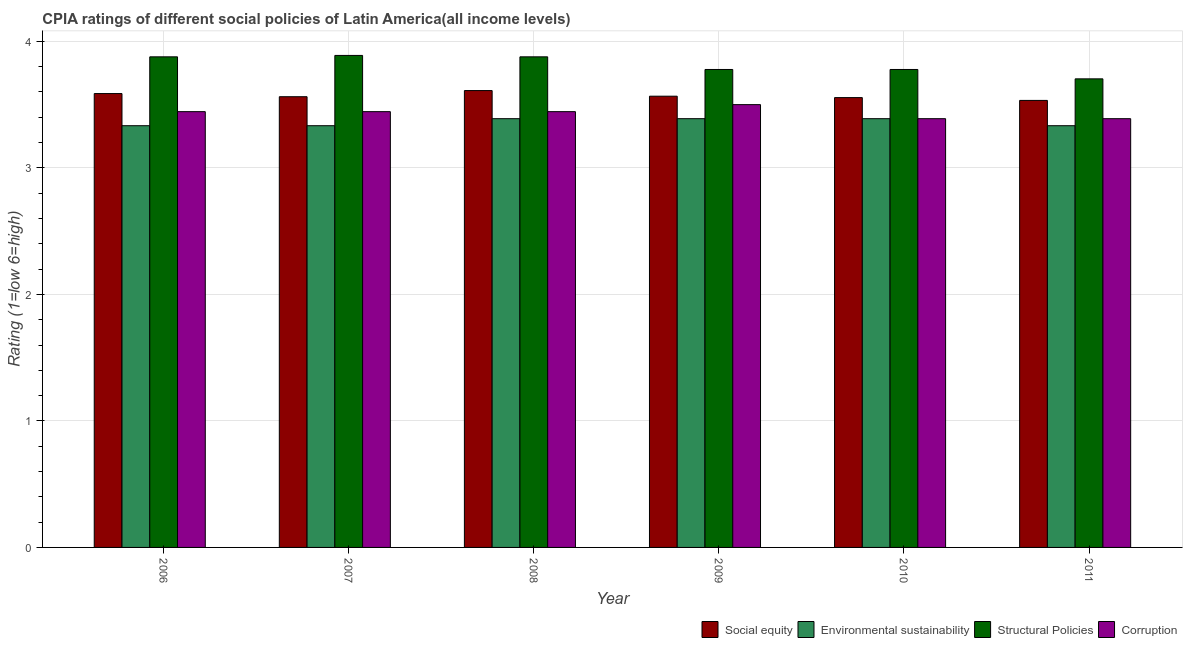How many different coloured bars are there?
Provide a succinct answer. 4. Are the number of bars per tick equal to the number of legend labels?
Provide a succinct answer. Yes. Are the number of bars on each tick of the X-axis equal?
Offer a very short reply. Yes. How many bars are there on the 2nd tick from the right?
Provide a short and direct response. 4. What is the cpia rating of environmental sustainability in 2011?
Ensure brevity in your answer.  3.33. Across all years, what is the maximum cpia rating of social equity?
Your answer should be very brief. 3.61. Across all years, what is the minimum cpia rating of environmental sustainability?
Offer a terse response. 3.33. What is the total cpia rating of environmental sustainability in the graph?
Offer a very short reply. 20.17. What is the difference between the cpia rating of structural policies in 2006 and that in 2007?
Ensure brevity in your answer.  -0.01. What is the difference between the cpia rating of social equity in 2009 and the cpia rating of environmental sustainability in 2011?
Offer a very short reply. 0.03. What is the average cpia rating of environmental sustainability per year?
Ensure brevity in your answer.  3.36. In how many years, is the cpia rating of environmental sustainability greater than 1.2?
Provide a succinct answer. 6. What is the ratio of the cpia rating of social equity in 2006 to that in 2007?
Offer a very short reply. 1.01. Is the cpia rating of environmental sustainability in 2006 less than that in 2009?
Offer a very short reply. Yes. What is the difference between the highest and the second highest cpia rating of social equity?
Provide a succinct answer. 0.02. What is the difference between the highest and the lowest cpia rating of structural policies?
Offer a very short reply. 0.19. Is it the case that in every year, the sum of the cpia rating of corruption and cpia rating of environmental sustainability is greater than the sum of cpia rating of social equity and cpia rating of structural policies?
Provide a succinct answer. Yes. What does the 2nd bar from the left in 2007 represents?
Your answer should be very brief. Environmental sustainability. What does the 1st bar from the right in 2007 represents?
Offer a terse response. Corruption. How many bars are there?
Give a very brief answer. 24. Are all the bars in the graph horizontal?
Your answer should be very brief. No. How many years are there in the graph?
Provide a short and direct response. 6. Does the graph contain any zero values?
Offer a very short reply. No. Does the graph contain grids?
Your response must be concise. Yes. How many legend labels are there?
Ensure brevity in your answer.  4. What is the title of the graph?
Your answer should be compact. CPIA ratings of different social policies of Latin America(all income levels). Does "First 20% of population" appear as one of the legend labels in the graph?
Offer a very short reply. No. What is the Rating (1=low 6=high) of Social equity in 2006?
Keep it short and to the point. 3.59. What is the Rating (1=low 6=high) of Environmental sustainability in 2006?
Make the answer very short. 3.33. What is the Rating (1=low 6=high) of Structural Policies in 2006?
Give a very brief answer. 3.88. What is the Rating (1=low 6=high) of Corruption in 2006?
Provide a short and direct response. 3.44. What is the Rating (1=low 6=high) of Social equity in 2007?
Make the answer very short. 3.56. What is the Rating (1=low 6=high) of Environmental sustainability in 2007?
Make the answer very short. 3.33. What is the Rating (1=low 6=high) of Structural Policies in 2007?
Offer a terse response. 3.89. What is the Rating (1=low 6=high) of Corruption in 2007?
Keep it short and to the point. 3.44. What is the Rating (1=low 6=high) of Social equity in 2008?
Your answer should be very brief. 3.61. What is the Rating (1=low 6=high) in Environmental sustainability in 2008?
Provide a short and direct response. 3.39. What is the Rating (1=low 6=high) in Structural Policies in 2008?
Offer a very short reply. 3.88. What is the Rating (1=low 6=high) of Corruption in 2008?
Your answer should be compact. 3.44. What is the Rating (1=low 6=high) in Social equity in 2009?
Your response must be concise. 3.57. What is the Rating (1=low 6=high) of Environmental sustainability in 2009?
Your answer should be compact. 3.39. What is the Rating (1=low 6=high) of Structural Policies in 2009?
Keep it short and to the point. 3.78. What is the Rating (1=low 6=high) of Corruption in 2009?
Your answer should be very brief. 3.5. What is the Rating (1=low 6=high) in Social equity in 2010?
Your answer should be compact. 3.56. What is the Rating (1=low 6=high) of Environmental sustainability in 2010?
Provide a succinct answer. 3.39. What is the Rating (1=low 6=high) of Structural Policies in 2010?
Keep it short and to the point. 3.78. What is the Rating (1=low 6=high) of Corruption in 2010?
Ensure brevity in your answer.  3.39. What is the Rating (1=low 6=high) of Social equity in 2011?
Your answer should be compact. 3.53. What is the Rating (1=low 6=high) of Environmental sustainability in 2011?
Your response must be concise. 3.33. What is the Rating (1=low 6=high) of Structural Policies in 2011?
Provide a succinct answer. 3.7. What is the Rating (1=low 6=high) in Corruption in 2011?
Keep it short and to the point. 3.39. Across all years, what is the maximum Rating (1=low 6=high) of Social equity?
Ensure brevity in your answer.  3.61. Across all years, what is the maximum Rating (1=low 6=high) in Environmental sustainability?
Offer a terse response. 3.39. Across all years, what is the maximum Rating (1=low 6=high) in Structural Policies?
Your response must be concise. 3.89. Across all years, what is the maximum Rating (1=low 6=high) of Corruption?
Offer a terse response. 3.5. Across all years, what is the minimum Rating (1=low 6=high) in Social equity?
Offer a terse response. 3.53. Across all years, what is the minimum Rating (1=low 6=high) in Environmental sustainability?
Your response must be concise. 3.33. Across all years, what is the minimum Rating (1=low 6=high) in Structural Policies?
Your answer should be very brief. 3.7. Across all years, what is the minimum Rating (1=low 6=high) in Corruption?
Offer a very short reply. 3.39. What is the total Rating (1=low 6=high) in Social equity in the graph?
Offer a terse response. 21.42. What is the total Rating (1=low 6=high) of Environmental sustainability in the graph?
Make the answer very short. 20.17. What is the total Rating (1=low 6=high) of Structural Policies in the graph?
Offer a very short reply. 22.9. What is the total Rating (1=low 6=high) of Corruption in the graph?
Keep it short and to the point. 20.61. What is the difference between the Rating (1=low 6=high) in Social equity in 2006 and that in 2007?
Make the answer very short. 0.03. What is the difference between the Rating (1=low 6=high) of Environmental sustainability in 2006 and that in 2007?
Your response must be concise. 0. What is the difference between the Rating (1=low 6=high) in Structural Policies in 2006 and that in 2007?
Your answer should be compact. -0.01. What is the difference between the Rating (1=low 6=high) in Corruption in 2006 and that in 2007?
Keep it short and to the point. 0. What is the difference between the Rating (1=low 6=high) in Social equity in 2006 and that in 2008?
Give a very brief answer. -0.02. What is the difference between the Rating (1=low 6=high) of Environmental sustainability in 2006 and that in 2008?
Ensure brevity in your answer.  -0.06. What is the difference between the Rating (1=low 6=high) in Corruption in 2006 and that in 2008?
Give a very brief answer. 0. What is the difference between the Rating (1=low 6=high) of Social equity in 2006 and that in 2009?
Offer a very short reply. 0.02. What is the difference between the Rating (1=low 6=high) of Environmental sustainability in 2006 and that in 2009?
Provide a succinct answer. -0.06. What is the difference between the Rating (1=low 6=high) of Structural Policies in 2006 and that in 2009?
Offer a terse response. 0.1. What is the difference between the Rating (1=low 6=high) in Corruption in 2006 and that in 2009?
Offer a terse response. -0.06. What is the difference between the Rating (1=low 6=high) of Social equity in 2006 and that in 2010?
Provide a succinct answer. 0.03. What is the difference between the Rating (1=low 6=high) in Environmental sustainability in 2006 and that in 2010?
Make the answer very short. -0.06. What is the difference between the Rating (1=low 6=high) in Structural Policies in 2006 and that in 2010?
Give a very brief answer. 0.1. What is the difference between the Rating (1=low 6=high) in Corruption in 2006 and that in 2010?
Your answer should be compact. 0.06. What is the difference between the Rating (1=low 6=high) in Social equity in 2006 and that in 2011?
Provide a short and direct response. 0.05. What is the difference between the Rating (1=low 6=high) of Structural Policies in 2006 and that in 2011?
Give a very brief answer. 0.17. What is the difference between the Rating (1=low 6=high) of Corruption in 2006 and that in 2011?
Provide a succinct answer. 0.06. What is the difference between the Rating (1=low 6=high) in Social equity in 2007 and that in 2008?
Ensure brevity in your answer.  -0.05. What is the difference between the Rating (1=low 6=high) in Environmental sustainability in 2007 and that in 2008?
Make the answer very short. -0.06. What is the difference between the Rating (1=low 6=high) of Structural Policies in 2007 and that in 2008?
Provide a succinct answer. 0.01. What is the difference between the Rating (1=low 6=high) in Social equity in 2007 and that in 2009?
Give a very brief answer. -0. What is the difference between the Rating (1=low 6=high) of Environmental sustainability in 2007 and that in 2009?
Ensure brevity in your answer.  -0.06. What is the difference between the Rating (1=low 6=high) of Corruption in 2007 and that in 2009?
Offer a very short reply. -0.06. What is the difference between the Rating (1=low 6=high) in Social equity in 2007 and that in 2010?
Make the answer very short. 0.01. What is the difference between the Rating (1=low 6=high) in Environmental sustainability in 2007 and that in 2010?
Your answer should be very brief. -0.06. What is the difference between the Rating (1=low 6=high) of Corruption in 2007 and that in 2010?
Ensure brevity in your answer.  0.06. What is the difference between the Rating (1=low 6=high) in Social equity in 2007 and that in 2011?
Your answer should be compact. 0.03. What is the difference between the Rating (1=low 6=high) in Environmental sustainability in 2007 and that in 2011?
Provide a succinct answer. 0. What is the difference between the Rating (1=low 6=high) of Structural Policies in 2007 and that in 2011?
Your answer should be very brief. 0.19. What is the difference between the Rating (1=low 6=high) of Corruption in 2007 and that in 2011?
Keep it short and to the point. 0.06. What is the difference between the Rating (1=low 6=high) of Social equity in 2008 and that in 2009?
Keep it short and to the point. 0.04. What is the difference between the Rating (1=low 6=high) in Environmental sustainability in 2008 and that in 2009?
Ensure brevity in your answer.  0. What is the difference between the Rating (1=low 6=high) in Structural Policies in 2008 and that in 2009?
Keep it short and to the point. 0.1. What is the difference between the Rating (1=low 6=high) in Corruption in 2008 and that in 2009?
Make the answer very short. -0.06. What is the difference between the Rating (1=low 6=high) of Social equity in 2008 and that in 2010?
Your answer should be compact. 0.06. What is the difference between the Rating (1=low 6=high) in Environmental sustainability in 2008 and that in 2010?
Ensure brevity in your answer.  0. What is the difference between the Rating (1=low 6=high) in Corruption in 2008 and that in 2010?
Offer a terse response. 0.06. What is the difference between the Rating (1=low 6=high) in Social equity in 2008 and that in 2011?
Your answer should be compact. 0.08. What is the difference between the Rating (1=low 6=high) in Environmental sustainability in 2008 and that in 2011?
Keep it short and to the point. 0.06. What is the difference between the Rating (1=low 6=high) in Structural Policies in 2008 and that in 2011?
Offer a terse response. 0.17. What is the difference between the Rating (1=low 6=high) in Corruption in 2008 and that in 2011?
Your answer should be compact. 0.06. What is the difference between the Rating (1=low 6=high) of Social equity in 2009 and that in 2010?
Give a very brief answer. 0.01. What is the difference between the Rating (1=low 6=high) of Corruption in 2009 and that in 2010?
Offer a terse response. 0.11. What is the difference between the Rating (1=low 6=high) in Environmental sustainability in 2009 and that in 2011?
Make the answer very short. 0.06. What is the difference between the Rating (1=low 6=high) of Structural Policies in 2009 and that in 2011?
Make the answer very short. 0.07. What is the difference between the Rating (1=low 6=high) of Corruption in 2009 and that in 2011?
Give a very brief answer. 0.11. What is the difference between the Rating (1=low 6=high) of Social equity in 2010 and that in 2011?
Provide a succinct answer. 0.02. What is the difference between the Rating (1=low 6=high) in Environmental sustainability in 2010 and that in 2011?
Your answer should be compact. 0.06. What is the difference between the Rating (1=low 6=high) of Structural Policies in 2010 and that in 2011?
Keep it short and to the point. 0.07. What is the difference between the Rating (1=low 6=high) in Corruption in 2010 and that in 2011?
Offer a very short reply. 0. What is the difference between the Rating (1=low 6=high) of Social equity in 2006 and the Rating (1=low 6=high) of Environmental sustainability in 2007?
Keep it short and to the point. 0.25. What is the difference between the Rating (1=low 6=high) in Social equity in 2006 and the Rating (1=low 6=high) in Structural Policies in 2007?
Offer a very short reply. -0.3. What is the difference between the Rating (1=low 6=high) of Social equity in 2006 and the Rating (1=low 6=high) of Corruption in 2007?
Ensure brevity in your answer.  0.14. What is the difference between the Rating (1=low 6=high) of Environmental sustainability in 2006 and the Rating (1=low 6=high) of Structural Policies in 2007?
Your answer should be very brief. -0.56. What is the difference between the Rating (1=low 6=high) in Environmental sustainability in 2006 and the Rating (1=low 6=high) in Corruption in 2007?
Provide a succinct answer. -0.11. What is the difference between the Rating (1=low 6=high) of Structural Policies in 2006 and the Rating (1=low 6=high) of Corruption in 2007?
Your response must be concise. 0.43. What is the difference between the Rating (1=low 6=high) of Social equity in 2006 and the Rating (1=low 6=high) of Environmental sustainability in 2008?
Your answer should be compact. 0.2. What is the difference between the Rating (1=low 6=high) of Social equity in 2006 and the Rating (1=low 6=high) of Structural Policies in 2008?
Ensure brevity in your answer.  -0.29. What is the difference between the Rating (1=low 6=high) of Social equity in 2006 and the Rating (1=low 6=high) of Corruption in 2008?
Offer a very short reply. 0.14. What is the difference between the Rating (1=low 6=high) of Environmental sustainability in 2006 and the Rating (1=low 6=high) of Structural Policies in 2008?
Provide a short and direct response. -0.54. What is the difference between the Rating (1=low 6=high) in Environmental sustainability in 2006 and the Rating (1=low 6=high) in Corruption in 2008?
Offer a terse response. -0.11. What is the difference between the Rating (1=low 6=high) of Structural Policies in 2006 and the Rating (1=low 6=high) of Corruption in 2008?
Ensure brevity in your answer.  0.43. What is the difference between the Rating (1=low 6=high) of Social equity in 2006 and the Rating (1=low 6=high) of Environmental sustainability in 2009?
Make the answer very short. 0.2. What is the difference between the Rating (1=low 6=high) in Social equity in 2006 and the Rating (1=low 6=high) in Structural Policies in 2009?
Offer a terse response. -0.19. What is the difference between the Rating (1=low 6=high) of Social equity in 2006 and the Rating (1=low 6=high) of Corruption in 2009?
Offer a very short reply. 0.09. What is the difference between the Rating (1=low 6=high) in Environmental sustainability in 2006 and the Rating (1=low 6=high) in Structural Policies in 2009?
Make the answer very short. -0.44. What is the difference between the Rating (1=low 6=high) in Structural Policies in 2006 and the Rating (1=low 6=high) in Corruption in 2009?
Ensure brevity in your answer.  0.38. What is the difference between the Rating (1=low 6=high) in Social equity in 2006 and the Rating (1=low 6=high) in Environmental sustainability in 2010?
Your answer should be compact. 0.2. What is the difference between the Rating (1=low 6=high) in Social equity in 2006 and the Rating (1=low 6=high) in Structural Policies in 2010?
Provide a short and direct response. -0.19. What is the difference between the Rating (1=low 6=high) in Social equity in 2006 and the Rating (1=low 6=high) in Corruption in 2010?
Provide a succinct answer. 0.2. What is the difference between the Rating (1=low 6=high) in Environmental sustainability in 2006 and the Rating (1=low 6=high) in Structural Policies in 2010?
Your response must be concise. -0.44. What is the difference between the Rating (1=low 6=high) of Environmental sustainability in 2006 and the Rating (1=low 6=high) of Corruption in 2010?
Keep it short and to the point. -0.06. What is the difference between the Rating (1=low 6=high) of Structural Policies in 2006 and the Rating (1=low 6=high) of Corruption in 2010?
Keep it short and to the point. 0.49. What is the difference between the Rating (1=low 6=high) in Social equity in 2006 and the Rating (1=low 6=high) in Environmental sustainability in 2011?
Your response must be concise. 0.25. What is the difference between the Rating (1=low 6=high) in Social equity in 2006 and the Rating (1=low 6=high) in Structural Policies in 2011?
Your answer should be very brief. -0.12. What is the difference between the Rating (1=low 6=high) in Social equity in 2006 and the Rating (1=low 6=high) in Corruption in 2011?
Your response must be concise. 0.2. What is the difference between the Rating (1=low 6=high) in Environmental sustainability in 2006 and the Rating (1=low 6=high) in Structural Policies in 2011?
Your answer should be very brief. -0.37. What is the difference between the Rating (1=low 6=high) in Environmental sustainability in 2006 and the Rating (1=low 6=high) in Corruption in 2011?
Ensure brevity in your answer.  -0.06. What is the difference between the Rating (1=low 6=high) of Structural Policies in 2006 and the Rating (1=low 6=high) of Corruption in 2011?
Your answer should be compact. 0.49. What is the difference between the Rating (1=low 6=high) of Social equity in 2007 and the Rating (1=low 6=high) of Environmental sustainability in 2008?
Your response must be concise. 0.17. What is the difference between the Rating (1=low 6=high) in Social equity in 2007 and the Rating (1=low 6=high) in Structural Policies in 2008?
Provide a short and direct response. -0.32. What is the difference between the Rating (1=low 6=high) in Social equity in 2007 and the Rating (1=low 6=high) in Corruption in 2008?
Give a very brief answer. 0.12. What is the difference between the Rating (1=low 6=high) in Environmental sustainability in 2007 and the Rating (1=low 6=high) in Structural Policies in 2008?
Provide a succinct answer. -0.54. What is the difference between the Rating (1=low 6=high) in Environmental sustainability in 2007 and the Rating (1=low 6=high) in Corruption in 2008?
Keep it short and to the point. -0.11. What is the difference between the Rating (1=low 6=high) of Structural Policies in 2007 and the Rating (1=low 6=high) of Corruption in 2008?
Offer a very short reply. 0.44. What is the difference between the Rating (1=low 6=high) in Social equity in 2007 and the Rating (1=low 6=high) in Environmental sustainability in 2009?
Ensure brevity in your answer.  0.17. What is the difference between the Rating (1=low 6=high) of Social equity in 2007 and the Rating (1=low 6=high) of Structural Policies in 2009?
Your response must be concise. -0.22. What is the difference between the Rating (1=low 6=high) in Social equity in 2007 and the Rating (1=low 6=high) in Corruption in 2009?
Offer a terse response. 0.06. What is the difference between the Rating (1=low 6=high) in Environmental sustainability in 2007 and the Rating (1=low 6=high) in Structural Policies in 2009?
Your response must be concise. -0.44. What is the difference between the Rating (1=low 6=high) of Environmental sustainability in 2007 and the Rating (1=low 6=high) of Corruption in 2009?
Ensure brevity in your answer.  -0.17. What is the difference between the Rating (1=low 6=high) of Structural Policies in 2007 and the Rating (1=low 6=high) of Corruption in 2009?
Provide a succinct answer. 0.39. What is the difference between the Rating (1=low 6=high) of Social equity in 2007 and the Rating (1=low 6=high) of Environmental sustainability in 2010?
Keep it short and to the point. 0.17. What is the difference between the Rating (1=low 6=high) in Social equity in 2007 and the Rating (1=low 6=high) in Structural Policies in 2010?
Ensure brevity in your answer.  -0.22. What is the difference between the Rating (1=low 6=high) of Social equity in 2007 and the Rating (1=low 6=high) of Corruption in 2010?
Provide a succinct answer. 0.17. What is the difference between the Rating (1=low 6=high) in Environmental sustainability in 2007 and the Rating (1=low 6=high) in Structural Policies in 2010?
Your response must be concise. -0.44. What is the difference between the Rating (1=low 6=high) of Environmental sustainability in 2007 and the Rating (1=low 6=high) of Corruption in 2010?
Give a very brief answer. -0.06. What is the difference between the Rating (1=low 6=high) in Social equity in 2007 and the Rating (1=low 6=high) in Environmental sustainability in 2011?
Keep it short and to the point. 0.23. What is the difference between the Rating (1=low 6=high) in Social equity in 2007 and the Rating (1=low 6=high) in Structural Policies in 2011?
Offer a terse response. -0.14. What is the difference between the Rating (1=low 6=high) of Social equity in 2007 and the Rating (1=low 6=high) of Corruption in 2011?
Your answer should be very brief. 0.17. What is the difference between the Rating (1=low 6=high) in Environmental sustainability in 2007 and the Rating (1=low 6=high) in Structural Policies in 2011?
Provide a succinct answer. -0.37. What is the difference between the Rating (1=low 6=high) of Environmental sustainability in 2007 and the Rating (1=low 6=high) of Corruption in 2011?
Provide a short and direct response. -0.06. What is the difference between the Rating (1=low 6=high) in Structural Policies in 2007 and the Rating (1=low 6=high) in Corruption in 2011?
Provide a short and direct response. 0.5. What is the difference between the Rating (1=low 6=high) in Social equity in 2008 and the Rating (1=low 6=high) in Environmental sustainability in 2009?
Ensure brevity in your answer.  0.22. What is the difference between the Rating (1=low 6=high) in Social equity in 2008 and the Rating (1=low 6=high) in Structural Policies in 2009?
Offer a terse response. -0.17. What is the difference between the Rating (1=low 6=high) of Environmental sustainability in 2008 and the Rating (1=low 6=high) of Structural Policies in 2009?
Ensure brevity in your answer.  -0.39. What is the difference between the Rating (1=low 6=high) of Environmental sustainability in 2008 and the Rating (1=low 6=high) of Corruption in 2009?
Keep it short and to the point. -0.11. What is the difference between the Rating (1=low 6=high) in Structural Policies in 2008 and the Rating (1=low 6=high) in Corruption in 2009?
Your answer should be compact. 0.38. What is the difference between the Rating (1=low 6=high) in Social equity in 2008 and the Rating (1=low 6=high) in Environmental sustainability in 2010?
Provide a short and direct response. 0.22. What is the difference between the Rating (1=low 6=high) in Social equity in 2008 and the Rating (1=low 6=high) in Structural Policies in 2010?
Make the answer very short. -0.17. What is the difference between the Rating (1=low 6=high) of Social equity in 2008 and the Rating (1=low 6=high) of Corruption in 2010?
Keep it short and to the point. 0.22. What is the difference between the Rating (1=low 6=high) of Environmental sustainability in 2008 and the Rating (1=low 6=high) of Structural Policies in 2010?
Ensure brevity in your answer.  -0.39. What is the difference between the Rating (1=low 6=high) of Environmental sustainability in 2008 and the Rating (1=low 6=high) of Corruption in 2010?
Offer a terse response. 0. What is the difference between the Rating (1=low 6=high) of Structural Policies in 2008 and the Rating (1=low 6=high) of Corruption in 2010?
Ensure brevity in your answer.  0.49. What is the difference between the Rating (1=low 6=high) of Social equity in 2008 and the Rating (1=low 6=high) of Environmental sustainability in 2011?
Offer a very short reply. 0.28. What is the difference between the Rating (1=low 6=high) of Social equity in 2008 and the Rating (1=low 6=high) of Structural Policies in 2011?
Provide a short and direct response. -0.09. What is the difference between the Rating (1=low 6=high) in Social equity in 2008 and the Rating (1=low 6=high) in Corruption in 2011?
Your answer should be very brief. 0.22. What is the difference between the Rating (1=low 6=high) in Environmental sustainability in 2008 and the Rating (1=low 6=high) in Structural Policies in 2011?
Provide a short and direct response. -0.31. What is the difference between the Rating (1=low 6=high) in Structural Policies in 2008 and the Rating (1=low 6=high) in Corruption in 2011?
Ensure brevity in your answer.  0.49. What is the difference between the Rating (1=low 6=high) in Social equity in 2009 and the Rating (1=low 6=high) in Environmental sustainability in 2010?
Give a very brief answer. 0.18. What is the difference between the Rating (1=low 6=high) of Social equity in 2009 and the Rating (1=low 6=high) of Structural Policies in 2010?
Your answer should be very brief. -0.21. What is the difference between the Rating (1=low 6=high) in Social equity in 2009 and the Rating (1=low 6=high) in Corruption in 2010?
Your answer should be compact. 0.18. What is the difference between the Rating (1=low 6=high) of Environmental sustainability in 2009 and the Rating (1=low 6=high) of Structural Policies in 2010?
Your answer should be compact. -0.39. What is the difference between the Rating (1=low 6=high) in Structural Policies in 2009 and the Rating (1=low 6=high) in Corruption in 2010?
Provide a short and direct response. 0.39. What is the difference between the Rating (1=low 6=high) of Social equity in 2009 and the Rating (1=low 6=high) of Environmental sustainability in 2011?
Offer a very short reply. 0.23. What is the difference between the Rating (1=low 6=high) in Social equity in 2009 and the Rating (1=low 6=high) in Structural Policies in 2011?
Give a very brief answer. -0.14. What is the difference between the Rating (1=low 6=high) of Social equity in 2009 and the Rating (1=low 6=high) of Corruption in 2011?
Keep it short and to the point. 0.18. What is the difference between the Rating (1=low 6=high) of Environmental sustainability in 2009 and the Rating (1=low 6=high) of Structural Policies in 2011?
Your answer should be compact. -0.31. What is the difference between the Rating (1=low 6=high) of Structural Policies in 2009 and the Rating (1=low 6=high) of Corruption in 2011?
Make the answer very short. 0.39. What is the difference between the Rating (1=low 6=high) in Social equity in 2010 and the Rating (1=low 6=high) in Environmental sustainability in 2011?
Your answer should be very brief. 0.22. What is the difference between the Rating (1=low 6=high) of Social equity in 2010 and the Rating (1=low 6=high) of Structural Policies in 2011?
Your answer should be very brief. -0.15. What is the difference between the Rating (1=low 6=high) of Environmental sustainability in 2010 and the Rating (1=low 6=high) of Structural Policies in 2011?
Your response must be concise. -0.31. What is the difference between the Rating (1=low 6=high) in Structural Policies in 2010 and the Rating (1=low 6=high) in Corruption in 2011?
Your response must be concise. 0.39. What is the average Rating (1=low 6=high) in Social equity per year?
Your answer should be compact. 3.57. What is the average Rating (1=low 6=high) in Environmental sustainability per year?
Give a very brief answer. 3.36. What is the average Rating (1=low 6=high) in Structural Policies per year?
Provide a short and direct response. 3.82. What is the average Rating (1=low 6=high) of Corruption per year?
Ensure brevity in your answer.  3.44. In the year 2006, what is the difference between the Rating (1=low 6=high) of Social equity and Rating (1=low 6=high) of Environmental sustainability?
Make the answer very short. 0.25. In the year 2006, what is the difference between the Rating (1=low 6=high) of Social equity and Rating (1=low 6=high) of Structural Policies?
Your response must be concise. -0.29. In the year 2006, what is the difference between the Rating (1=low 6=high) in Social equity and Rating (1=low 6=high) in Corruption?
Your answer should be compact. 0.14. In the year 2006, what is the difference between the Rating (1=low 6=high) of Environmental sustainability and Rating (1=low 6=high) of Structural Policies?
Your answer should be very brief. -0.54. In the year 2006, what is the difference between the Rating (1=low 6=high) in Environmental sustainability and Rating (1=low 6=high) in Corruption?
Give a very brief answer. -0.11. In the year 2006, what is the difference between the Rating (1=low 6=high) in Structural Policies and Rating (1=low 6=high) in Corruption?
Give a very brief answer. 0.43. In the year 2007, what is the difference between the Rating (1=low 6=high) in Social equity and Rating (1=low 6=high) in Environmental sustainability?
Your response must be concise. 0.23. In the year 2007, what is the difference between the Rating (1=low 6=high) in Social equity and Rating (1=low 6=high) in Structural Policies?
Your answer should be very brief. -0.33. In the year 2007, what is the difference between the Rating (1=low 6=high) in Social equity and Rating (1=low 6=high) in Corruption?
Keep it short and to the point. 0.12. In the year 2007, what is the difference between the Rating (1=low 6=high) in Environmental sustainability and Rating (1=low 6=high) in Structural Policies?
Make the answer very short. -0.56. In the year 2007, what is the difference between the Rating (1=low 6=high) in Environmental sustainability and Rating (1=low 6=high) in Corruption?
Provide a short and direct response. -0.11. In the year 2007, what is the difference between the Rating (1=low 6=high) of Structural Policies and Rating (1=low 6=high) of Corruption?
Your answer should be very brief. 0.44. In the year 2008, what is the difference between the Rating (1=low 6=high) of Social equity and Rating (1=low 6=high) of Environmental sustainability?
Your answer should be compact. 0.22. In the year 2008, what is the difference between the Rating (1=low 6=high) in Social equity and Rating (1=low 6=high) in Structural Policies?
Make the answer very short. -0.27. In the year 2008, what is the difference between the Rating (1=low 6=high) in Environmental sustainability and Rating (1=low 6=high) in Structural Policies?
Make the answer very short. -0.49. In the year 2008, what is the difference between the Rating (1=low 6=high) of Environmental sustainability and Rating (1=low 6=high) of Corruption?
Your response must be concise. -0.06. In the year 2008, what is the difference between the Rating (1=low 6=high) in Structural Policies and Rating (1=low 6=high) in Corruption?
Provide a succinct answer. 0.43. In the year 2009, what is the difference between the Rating (1=low 6=high) of Social equity and Rating (1=low 6=high) of Environmental sustainability?
Your response must be concise. 0.18. In the year 2009, what is the difference between the Rating (1=low 6=high) in Social equity and Rating (1=low 6=high) in Structural Policies?
Provide a succinct answer. -0.21. In the year 2009, what is the difference between the Rating (1=low 6=high) of Social equity and Rating (1=low 6=high) of Corruption?
Your response must be concise. 0.07. In the year 2009, what is the difference between the Rating (1=low 6=high) of Environmental sustainability and Rating (1=low 6=high) of Structural Policies?
Keep it short and to the point. -0.39. In the year 2009, what is the difference between the Rating (1=low 6=high) in Environmental sustainability and Rating (1=low 6=high) in Corruption?
Offer a terse response. -0.11. In the year 2009, what is the difference between the Rating (1=low 6=high) in Structural Policies and Rating (1=low 6=high) in Corruption?
Provide a short and direct response. 0.28. In the year 2010, what is the difference between the Rating (1=low 6=high) in Social equity and Rating (1=low 6=high) in Environmental sustainability?
Ensure brevity in your answer.  0.17. In the year 2010, what is the difference between the Rating (1=low 6=high) of Social equity and Rating (1=low 6=high) of Structural Policies?
Offer a terse response. -0.22. In the year 2010, what is the difference between the Rating (1=low 6=high) in Social equity and Rating (1=low 6=high) in Corruption?
Provide a short and direct response. 0.17. In the year 2010, what is the difference between the Rating (1=low 6=high) in Environmental sustainability and Rating (1=low 6=high) in Structural Policies?
Your answer should be very brief. -0.39. In the year 2010, what is the difference between the Rating (1=low 6=high) in Structural Policies and Rating (1=low 6=high) in Corruption?
Offer a terse response. 0.39. In the year 2011, what is the difference between the Rating (1=low 6=high) in Social equity and Rating (1=low 6=high) in Environmental sustainability?
Provide a succinct answer. 0.2. In the year 2011, what is the difference between the Rating (1=low 6=high) in Social equity and Rating (1=low 6=high) in Structural Policies?
Your answer should be very brief. -0.17. In the year 2011, what is the difference between the Rating (1=low 6=high) of Social equity and Rating (1=low 6=high) of Corruption?
Provide a short and direct response. 0.14. In the year 2011, what is the difference between the Rating (1=low 6=high) in Environmental sustainability and Rating (1=low 6=high) in Structural Policies?
Keep it short and to the point. -0.37. In the year 2011, what is the difference between the Rating (1=low 6=high) in Environmental sustainability and Rating (1=low 6=high) in Corruption?
Provide a short and direct response. -0.06. In the year 2011, what is the difference between the Rating (1=low 6=high) of Structural Policies and Rating (1=low 6=high) of Corruption?
Your response must be concise. 0.31. What is the ratio of the Rating (1=low 6=high) of Social equity in 2006 to that in 2007?
Provide a succinct answer. 1.01. What is the ratio of the Rating (1=low 6=high) of Corruption in 2006 to that in 2007?
Offer a very short reply. 1. What is the ratio of the Rating (1=low 6=high) in Environmental sustainability in 2006 to that in 2008?
Provide a succinct answer. 0.98. What is the ratio of the Rating (1=low 6=high) of Social equity in 2006 to that in 2009?
Make the answer very short. 1.01. What is the ratio of the Rating (1=low 6=high) of Environmental sustainability in 2006 to that in 2009?
Provide a short and direct response. 0.98. What is the ratio of the Rating (1=low 6=high) in Structural Policies in 2006 to that in 2009?
Your response must be concise. 1.03. What is the ratio of the Rating (1=low 6=high) in Corruption in 2006 to that in 2009?
Give a very brief answer. 0.98. What is the ratio of the Rating (1=low 6=high) of Environmental sustainability in 2006 to that in 2010?
Your answer should be very brief. 0.98. What is the ratio of the Rating (1=low 6=high) in Structural Policies in 2006 to that in 2010?
Your answer should be very brief. 1.03. What is the ratio of the Rating (1=low 6=high) of Corruption in 2006 to that in 2010?
Provide a succinct answer. 1.02. What is the ratio of the Rating (1=low 6=high) in Social equity in 2006 to that in 2011?
Offer a terse response. 1.02. What is the ratio of the Rating (1=low 6=high) in Structural Policies in 2006 to that in 2011?
Offer a very short reply. 1.05. What is the ratio of the Rating (1=low 6=high) of Corruption in 2006 to that in 2011?
Your response must be concise. 1.02. What is the ratio of the Rating (1=low 6=high) of Social equity in 2007 to that in 2008?
Provide a short and direct response. 0.99. What is the ratio of the Rating (1=low 6=high) in Environmental sustainability in 2007 to that in 2008?
Keep it short and to the point. 0.98. What is the ratio of the Rating (1=low 6=high) in Structural Policies in 2007 to that in 2008?
Offer a terse response. 1. What is the ratio of the Rating (1=low 6=high) in Corruption in 2007 to that in 2008?
Your answer should be very brief. 1. What is the ratio of the Rating (1=low 6=high) in Social equity in 2007 to that in 2009?
Provide a succinct answer. 1. What is the ratio of the Rating (1=low 6=high) in Environmental sustainability in 2007 to that in 2009?
Offer a terse response. 0.98. What is the ratio of the Rating (1=low 6=high) of Structural Policies in 2007 to that in 2009?
Provide a succinct answer. 1.03. What is the ratio of the Rating (1=low 6=high) of Corruption in 2007 to that in 2009?
Provide a short and direct response. 0.98. What is the ratio of the Rating (1=low 6=high) of Social equity in 2007 to that in 2010?
Your answer should be very brief. 1. What is the ratio of the Rating (1=low 6=high) in Environmental sustainability in 2007 to that in 2010?
Offer a very short reply. 0.98. What is the ratio of the Rating (1=low 6=high) in Structural Policies in 2007 to that in 2010?
Offer a very short reply. 1.03. What is the ratio of the Rating (1=low 6=high) in Corruption in 2007 to that in 2010?
Your answer should be compact. 1.02. What is the ratio of the Rating (1=low 6=high) of Social equity in 2007 to that in 2011?
Provide a succinct answer. 1.01. What is the ratio of the Rating (1=low 6=high) of Structural Policies in 2007 to that in 2011?
Your answer should be very brief. 1.05. What is the ratio of the Rating (1=low 6=high) in Corruption in 2007 to that in 2011?
Offer a very short reply. 1.02. What is the ratio of the Rating (1=low 6=high) of Social equity in 2008 to that in 2009?
Your response must be concise. 1.01. What is the ratio of the Rating (1=low 6=high) in Environmental sustainability in 2008 to that in 2009?
Provide a short and direct response. 1. What is the ratio of the Rating (1=low 6=high) in Structural Policies in 2008 to that in 2009?
Your answer should be very brief. 1.03. What is the ratio of the Rating (1=low 6=high) in Corruption in 2008 to that in 2009?
Ensure brevity in your answer.  0.98. What is the ratio of the Rating (1=low 6=high) in Social equity in 2008 to that in 2010?
Your answer should be very brief. 1.02. What is the ratio of the Rating (1=low 6=high) of Structural Policies in 2008 to that in 2010?
Give a very brief answer. 1.03. What is the ratio of the Rating (1=low 6=high) in Corruption in 2008 to that in 2010?
Provide a succinct answer. 1.02. What is the ratio of the Rating (1=low 6=high) of Environmental sustainability in 2008 to that in 2011?
Your answer should be very brief. 1.02. What is the ratio of the Rating (1=low 6=high) in Structural Policies in 2008 to that in 2011?
Your response must be concise. 1.05. What is the ratio of the Rating (1=low 6=high) in Corruption in 2008 to that in 2011?
Keep it short and to the point. 1.02. What is the ratio of the Rating (1=low 6=high) in Social equity in 2009 to that in 2010?
Keep it short and to the point. 1. What is the ratio of the Rating (1=low 6=high) of Environmental sustainability in 2009 to that in 2010?
Ensure brevity in your answer.  1. What is the ratio of the Rating (1=low 6=high) in Structural Policies in 2009 to that in 2010?
Provide a short and direct response. 1. What is the ratio of the Rating (1=low 6=high) of Corruption in 2009 to that in 2010?
Offer a very short reply. 1.03. What is the ratio of the Rating (1=low 6=high) of Social equity in 2009 to that in 2011?
Keep it short and to the point. 1.01. What is the ratio of the Rating (1=low 6=high) in Environmental sustainability in 2009 to that in 2011?
Keep it short and to the point. 1.02. What is the ratio of the Rating (1=low 6=high) of Structural Policies in 2009 to that in 2011?
Provide a succinct answer. 1.02. What is the ratio of the Rating (1=low 6=high) in Corruption in 2009 to that in 2011?
Provide a succinct answer. 1.03. What is the ratio of the Rating (1=low 6=high) in Social equity in 2010 to that in 2011?
Give a very brief answer. 1.01. What is the ratio of the Rating (1=low 6=high) in Environmental sustainability in 2010 to that in 2011?
Your response must be concise. 1.02. What is the ratio of the Rating (1=low 6=high) of Corruption in 2010 to that in 2011?
Your answer should be compact. 1. What is the difference between the highest and the second highest Rating (1=low 6=high) in Social equity?
Your answer should be very brief. 0.02. What is the difference between the highest and the second highest Rating (1=low 6=high) of Structural Policies?
Make the answer very short. 0.01. What is the difference between the highest and the second highest Rating (1=low 6=high) of Corruption?
Ensure brevity in your answer.  0.06. What is the difference between the highest and the lowest Rating (1=low 6=high) of Social equity?
Provide a short and direct response. 0.08. What is the difference between the highest and the lowest Rating (1=low 6=high) of Environmental sustainability?
Offer a terse response. 0.06. What is the difference between the highest and the lowest Rating (1=low 6=high) in Structural Policies?
Ensure brevity in your answer.  0.19. What is the difference between the highest and the lowest Rating (1=low 6=high) in Corruption?
Give a very brief answer. 0.11. 